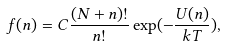Convert formula to latex. <formula><loc_0><loc_0><loc_500><loc_500>f ( n ) = C \frac { ( N + n ) ! } { n ! } \exp ( - \frac { U ( n ) } { k T } ) ,</formula> 